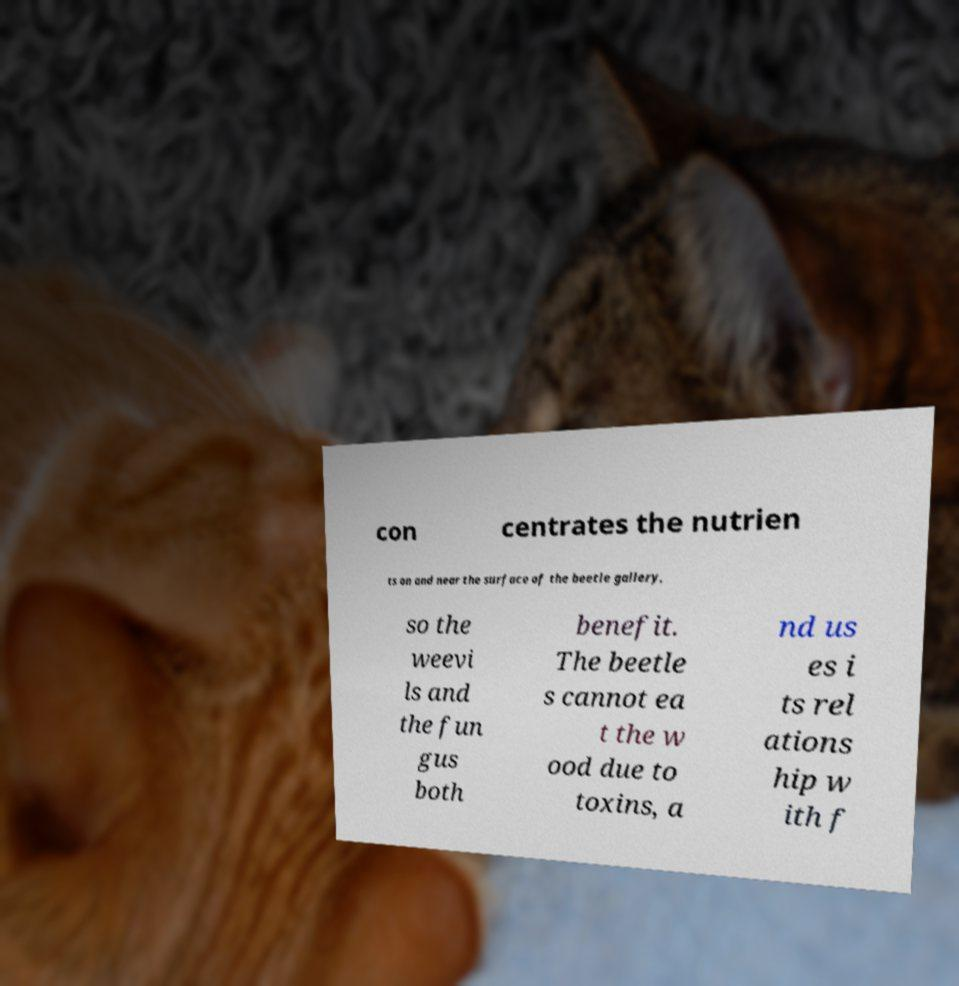Can you accurately transcribe the text from the provided image for me? con centrates the nutrien ts on and near the surface of the beetle gallery, so the weevi ls and the fun gus both benefit. The beetle s cannot ea t the w ood due to toxins, a nd us es i ts rel ations hip w ith f 